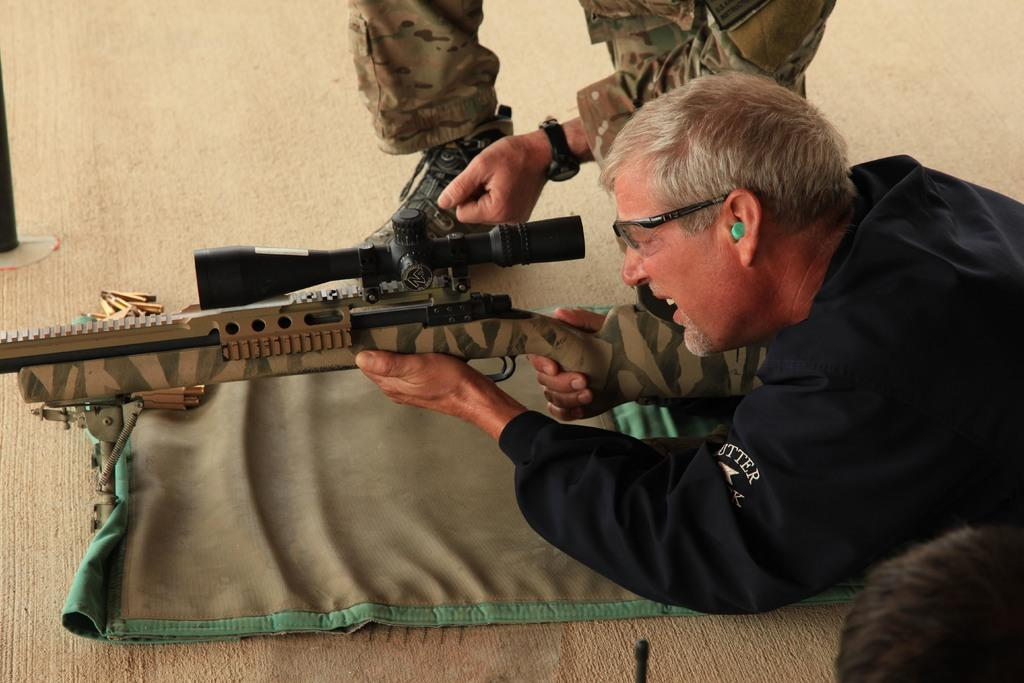What is the man in the image holding? The man is holding a gun in the image. Can you describe the other person in the image? There is another man in the foreground area of the image. What type of pet can be seen swimming in the image? There is no pet visible in the image, let alone one swimming. 